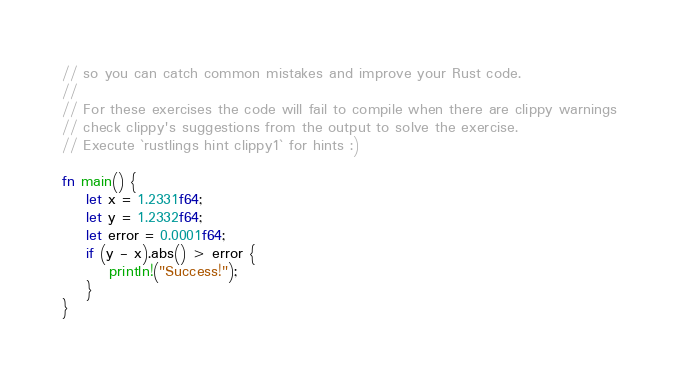Convert code to text. <code><loc_0><loc_0><loc_500><loc_500><_Rust_>// so you can catch common mistakes and improve your Rust code.
//
// For these exercises the code will fail to compile when there are clippy warnings
// check clippy's suggestions from the output to solve the exercise.
// Execute `rustlings hint clippy1` for hints :)

fn main() {
    let x = 1.2331f64;
    let y = 1.2332f64;
    let error = 0.0001f64;
    if (y - x).abs() > error {
        println!("Success!");
    }
}
</code> 